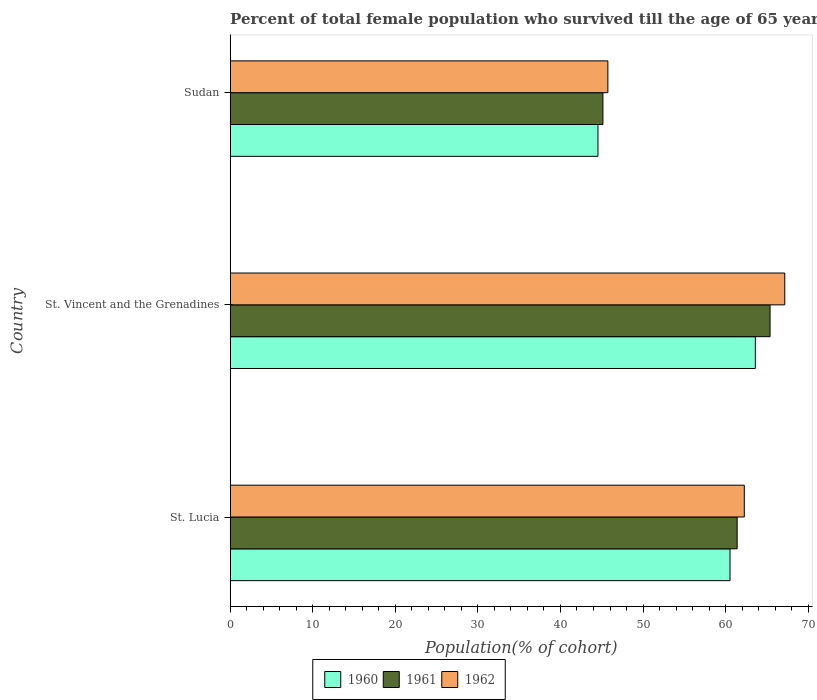Are the number of bars per tick equal to the number of legend labels?
Your answer should be compact. Yes. Are the number of bars on each tick of the Y-axis equal?
Give a very brief answer. Yes. How many bars are there on the 3rd tick from the bottom?
Make the answer very short. 3. What is the label of the 2nd group of bars from the top?
Your answer should be compact. St. Vincent and the Grenadines. In how many cases, is the number of bars for a given country not equal to the number of legend labels?
Make the answer very short. 0. What is the percentage of total female population who survived till the age of 65 years in 1961 in Sudan?
Your answer should be compact. 45.14. Across all countries, what is the maximum percentage of total female population who survived till the age of 65 years in 1962?
Ensure brevity in your answer.  67.17. Across all countries, what is the minimum percentage of total female population who survived till the age of 65 years in 1962?
Offer a very short reply. 45.74. In which country was the percentage of total female population who survived till the age of 65 years in 1962 maximum?
Offer a very short reply. St. Vincent and the Grenadines. In which country was the percentage of total female population who survived till the age of 65 years in 1962 minimum?
Ensure brevity in your answer.  Sudan. What is the total percentage of total female population who survived till the age of 65 years in 1961 in the graph?
Give a very brief answer. 171.93. What is the difference between the percentage of total female population who survived till the age of 65 years in 1962 in St. Lucia and that in Sudan?
Ensure brevity in your answer.  16.52. What is the difference between the percentage of total female population who survived till the age of 65 years in 1960 in St. Vincent and the Grenadines and the percentage of total female population who survived till the age of 65 years in 1961 in St. Lucia?
Provide a short and direct response. 2.2. What is the average percentage of total female population who survived till the age of 65 years in 1960 per country?
Ensure brevity in your answer.  56.23. What is the difference between the percentage of total female population who survived till the age of 65 years in 1960 and percentage of total female population who survived till the age of 65 years in 1961 in St. Lucia?
Give a very brief answer. -0.86. In how many countries, is the percentage of total female population who survived till the age of 65 years in 1960 greater than 28 %?
Your answer should be compact. 3. What is the ratio of the percentage of total female population who survived till the age of 65 years in 1961 in St. Lucia to that in Sudan?
Your answer should be very brief. 1.36. Is the difference between the percentage of total female population who survived till the age of 65 years in 1960 in St. Lucia and St. Vincent and the Grenadines greater than the difference between the percentage of total female population who survived till the age of 65 years in 1961 in St. Lucia and St. Vincent and the Grenadines?
Ensure brevity in your answer.  Yes. What is the difference between the highest and the second highest percentage of total female population who survived till the age of 65 years in 1961?
Your answer should be compact. 3.98. What is the difference between the highest and the lowest percentage of total female population who survived till the age of 65 years in 1962?
Your response must be concise. 21.42. In how many countries, is the percentage of total female population who survived till the age of 65 years in 1960 greater than the average percentage of total female population who survived till the age of 65 years in 1960 taken over all countries?
Keep it short and to the point. 2. Is the sum of the percentage of total female population who survived till the age of 65 years in 1961 in St. Lucia and St. Vincent and the Grenadines greater than the maximum percentage of total female population who survived till the age of 65 years in 1960 across all countries?
Provide a succinct answer. Yes. What does the 3rd bar from the top in Sudan represents?
Provide a short and direct response. 1960. What does the 1st bar from the bottom in Sudan represents?
Provide a short and direct response. 1960. What is the difference between two consecutive major ticks on the X-axis?
Offer a terse response. 10. Are the values on the major ticks of X-axis written in scientific E-notation?
Your response must be concise. No. Does the graph contain any zero values?
Offer a terse response. No. Where does the legend appear in the graph?
Your answer should be compact. Bottom center. How many legend labels are there?
Your response must be concise. 3. What is the title of the graph?
Keep it short and to the point. Percent of total female population who survived till the age of 65 years. Does "1984" appear as one of the legend labels in the graph?
Your answer should be compact. No. What is the label or title of the X-axis?
Keep it short and to the point. Population(% of cohort). What is the label or title of the Y-axis?
Ensure brevity in your answer.  Country. What is the Population(% of cohort) in 1960 in St. Lucia?
Offer a very short reply. 60.54. What is the Population(% of cohort) of 1961 in St. Lucia?
Offer a very short reply. 61.4. What is the Population(% of cohort) of 1962 in St. Lucia?
Provide a succinct answer. 62.26. What is the Population(% of cohort) of 1960 in St. Vincent and the Grenadines?
Your response must be concise. 63.6. What is the Population(% of cohort) of 1961 in St. Vincent and the Grenadines?
Offer a terse response. 65.39. What is the Population(% of cohort) in 1962 in St. Vincent and the Grenadines?
Ensure brevity in your answer.  67.17. What is the Population(% of cohort) of 1960 in Sudan?
Provide a short and direct response. 44.54. What is the Population(% of cohort) of 1961 in Sudan?
Provide a succinct answer. 45.14. What is the Population(% of cohort) of 1962 in Sudan?
Keep it short and to the point. 45.74. Across all countries, what is the maximum Population(% of cohort) of 1960?
Provide a short and direct response. 63.6. Across all countries, what is the maximum Population(% of cohort) in 1961?
Provide a succinct answer. 65.39. Across all countries, what is the maximum Population(% of cohort) in 1962?
Provide a short and direct response. 67.17. Across all countries, what is the minimum Population(% of cohort) in 1960?
Ensure brevity in your answer.  44.54. Across all countries, what is the minimum Population(% of cohort) of 1961?
Your response must be concise. 45.14. Across all countries, what is the minimum Population(% of cohort) in 1962?
Your response must be concise. 45.74. What is the total Population(% of cohort) in 1960 in the graph?
Make the answer very short. 168.68. What is the total Population(% of cohort) of 1961 in the graph?
Ensure brevity in your answer.  171.93. What is the total Population(% of cohort) in 1962 in the graph?
Make the answer very short. 175.18. What is the difference between the Population(% of cohort) of 1960 in St. Lucia and that in St. Vincent and the Grenadines?
Your response must be concise. -3.07. What is the difference between the Population(% of cohort) in 1961 in St. Lucia and that in St. Vincent and the Grenadines?
Ensure brevity in your answer.  -3.98. What is the difference between the Population(% of cohort) in 1962 in St. Lucia and that in St. Vincent and the Grenadines?
Ensure brevity in your answer.  -4.9. What is the difference between the Population(% of cohort) of 1960 in St. Lucia and that in Sudan?
Your response must be concise. 16. What is the difference between the Population(% of cohort) of 1961 in St. Lucia and that in Sudan?
Offer a very short reply. 16.26. What is the difference between the Population(% of cohort) of 1962 in St. Lucia and that in Sudan?
Your answer should be very brief. 16.52. What is the difference between the Population(% of cohort) in 1960 in St. Vincent and the Grenadines and that in Sudan?
Ensure brevity in your answer.  19.06. What is the difference between the Population(% of cohort) of 1961 in St. Vincent and the Grenadines and that in Sudan?
Provide a succinct answer. 20.24. What is the difference between the Population(% of cohort) of 1962 in St. Vincent and the Grenadines and that in Sudan?
Ensure brevity in your answer.  21.42. What is the difference between the Population(% of cohort) in 1960 in St. Lucia and the Population(% of cohort) in 1961 in St. Vincent and the Grenadines?
Ensure brevity in your answer.  -4.85. What is the difference between the Population(% of cohort) of 1960 in St. Lucia and the Population(% of cohort) of 1962 in St. Vincent and the Grenadines?
Offer a terse response. -6.63. What is the difference between the Population(% of cohort) in 1961 in St. Lucia and the Population(% of cohort) in 1962 in St. Vincent and the Grenadines?
Provide a succinct answer. -5.77. What is the difference between the Population(% of cohort) of 1960 in St. Lucia and the Population(% of cohort) of 1961 in Sudan?
Provide a short and direct response. 15.39. What is the difference between the Population(% of cohort) in 1960 in St. Lucia and the Population(% of cohort) in 1962 in Sudan?
Offer a very short reply. 14.79. What is the difference between the Population(% of cohort) of 1961 in St. Lucia and the Population(% of cohort) of 1962 in Sudan?
Offer a very short reply. 15.66. What is the difference between the Population(% of cohort) in 1960 in St. Vincent and the Grenadines and the Population(% of cohort) in 1961 in Sudan?
Your answer should be compact. 18.46. What is the difference between the Population(% of cohort) in 1960 in St. Vincent and the Grenadines and the Population(% of cohort) in 1962 in Sudan?
Ensure brevity in your answer.  17.86. What is the difference between the Population(% of cohort) in 1961 in St. Vincent and the Grenadines and the Population(% of cohort) in 1962 in Sudan?
Make the answer very short. 19.64. What is the average Population(% of cohort) in 1960 per country?
Ensure brevity in your answer.  56.23. What is the average Population(% of cohort) in 1961 per country?
Offer a very short reply. 57.31. What is the average Population(% of cohort) in 1962 per country?
Make the answer very short. 58.39. What is the difference between the Population(% of cohort) of 1960 and Population(% of cohort) of 1961 in St. Lucia?
Ensure brevity in your answer.  -0.86. What is the difference between the Population(% of cohort) of 1960 and Population(% of cohort) of 1962 in St. Lucia?
Your answer should be compact. -1.73. What is the difference between the Population(% of cohort) of 1961 and Population(% of cohort) of 1962 in St. Lucia?
Provide a succinct answer. -0.86. What is the difference between the Population(% of cohort) in 1960 and Population(% of cohort) in 1961 in St. Vincent and the Grenadines?
Your response must be concise. -1.78. What is the difference between the Population(% of cohort) of 1960 and Population(% of cohort) of 1962 in St. Vincent and the Grenadines?
Provide a short and direct response. -3.56. What is the difference between the Population(% of cohort) of 1961 and Population(% of cohort) of 1962 in St. Vincent and the Grenadines?
Make the answer very short. -1.78. What is the difference between the Population(% of cohort) of 1960 and Population(% of cohort) of 1961 in Sudan?
Give a very brief answer. -0.6. What is the difference between the Population(% of cohort) in 1960 and Population(% of cohort) in 1962 in Sudan?
Make the answer very short. -1.2. What is the difference between the Population(% of cohort) of 1961 and Population(% of cohort) of 1962 in Sudan?
Provide a succinct answer. -0.6. What is the ratio of the Population(% of cohort) of 1960 in St. Lucia to that in St. Vincent and the Grenadines?
Ensure brevity in your answer.  0.95. What is the ratio of the Population(% of cohort) of 1961 in St. Lucia to that in St. Vincent and the Grenadines?
Offer a very short reply. 0.94. What is the ratio of the Population(% of cohort) of 1962 in St. Lucia to that in St. Vincent and the Grenadines?
Offer a very short reply. 0.93. What is the ratio of the Population(% of cohort) in 1960 in St. Lucia to that in Sudan?
Offer a terse response. 1.36. What is the ratio of the Population(% of cohort) in 1961 in St. Lucia to that in Sudan?
Make the answer very short. 1.36. What is the ratio of the Population(% of cohort) of 1962 in St. Lucia to that in Sudan?
Your response must be concise. 1.36. What is the ratio of the Population(% of cohort) of 1960 in St. Vincent and the Grenadines to that in Sudan?
Your response must be concise. 1.43. What is the ratio of the Population(% of cohort) of 1961 in St. Vincent and the Grenadines to that in Sudan?
Offer a terse response. 1.45. What is the ratio of the Population(% of cohort) of 1962 in St. Vincent and the Grenadines to that in Sudan?
Your answer should be compact. 1.47. What is the difference between the highest and the second highest Population(% of cohort) of 1960?
Keep it short and to the point. 3.07. What is the difference between the highest and the second highest Population(% of cohort) in 1961?
Offer a very short reply. 3.98. What is the difference between the highest and the second highest Population(% of cohort) of 1962?
Provide a succinct answer. 4.9. What is the difference between the highest and the lowest Population(% of cohort) of 1960?
Your answer should be very brief. 19.06. What is the difference between the highest and the lowest Population(% of cohort) in 1961?
Provide a succinct answer. 20.24. What is the difference between the highest and the lowest Population(% of cohort) of 1962?
Give a very brief answer. 21.42. 